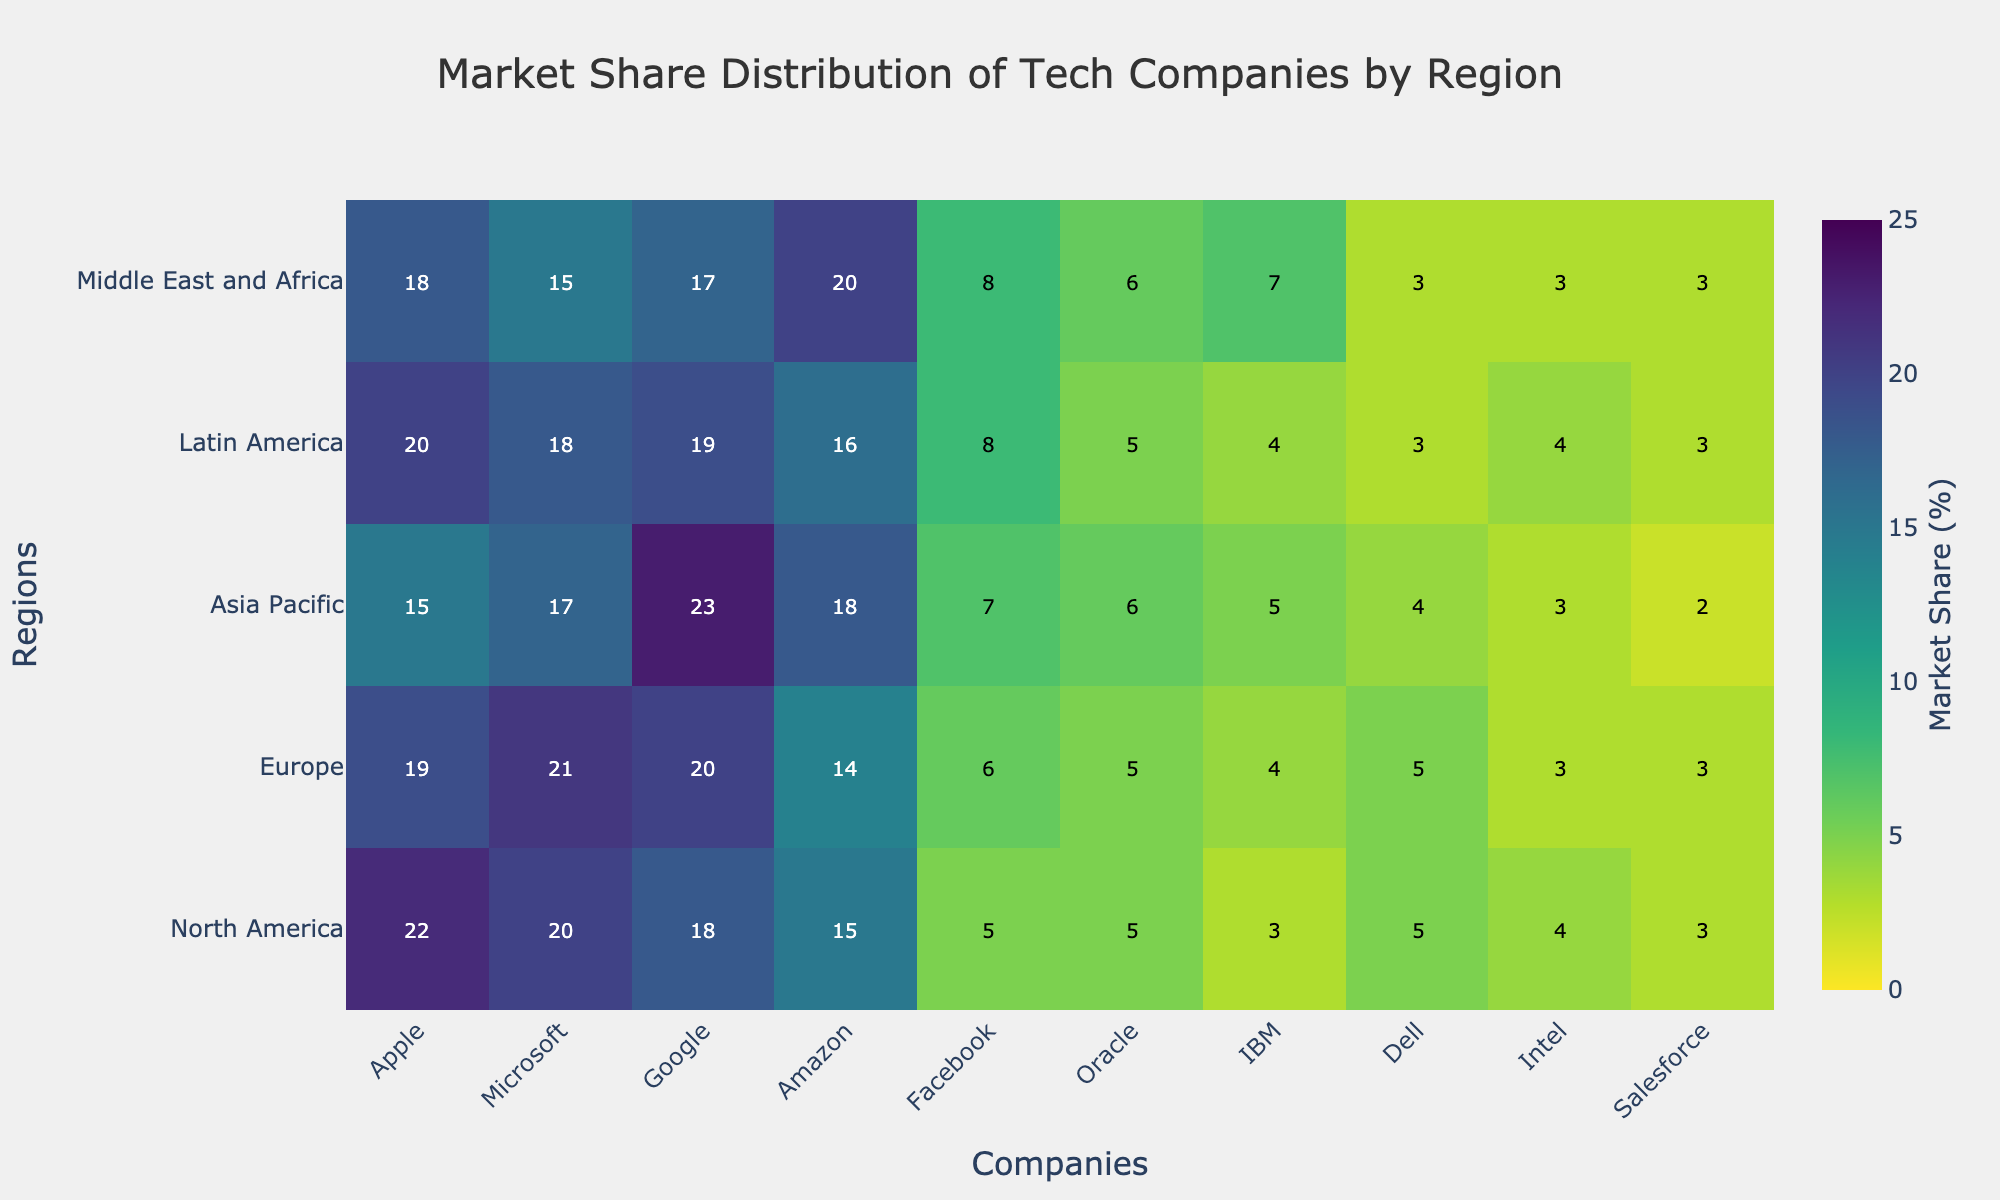What is the title of the heatmap? The title is prominently displayed at the top of the heatmap. It reads 'Market Share Distribution of Tech Companies by Region'.
Answer: Market Share Distribution of Tech Companies by Region Which company has the highest market share in Asia Pacific? First, locate the column for each company in the Asia Pacific row. Google has the highest value at 23%.
Answer: Google How many regions are represented in the heatmap? Check the y-axis labels from top to bottom. There are five regions: North America, Europe, Asia Pacific, Latin America, and Middle East and Africa.
Answer: 5 Which region has the smallest market share for Oracle? Find the smallest value in Oracle’s column across all regions. In the Asia Pacific region, Oracle has the smallest market share at 5%.
Answer: Asia Pacific What's the total market share for Microsoft across all regions? Sum Microsoft’s values for each region: 20 (North America) + 21 (Europe) + 17 (Asia Pacific) + 18 (Latin America) + 15 (Middle East and Africa) = 91%.
Answer: 91% Which two companies have an equal market share in Europe? Looking at the Europe row, Apple and Intel both have a market share of 20%.
Answer: Apple and Intel Which company has the most consistent market share across all regions? Check the values for each company in all regions for consistency. Dell has minor variations (3, 3, 4, 3, 3), indicating the most consistent market share.
Answer: Dell How does Facebook's market share in the Middle East and Africa compare to its market share in Latin America? Compare the two values: Facebook has 8% in both Middle East and Africa and Latin America, so they are equal.
Answer: Equal What is the average market share of Amazon across all regions? Add Amazon’s values and divide by the number of regions: (15 + 14 + 18 + 16 + 20) / 5 = 83 / 5 = 16.6%.
Answer: 16.6% Which company dominates the market share in tech across the Middle East and Africa? Identify the highest value in the Middle East and Africa row. Amazon has the highest market share at 20%.
Answer: Amazon 